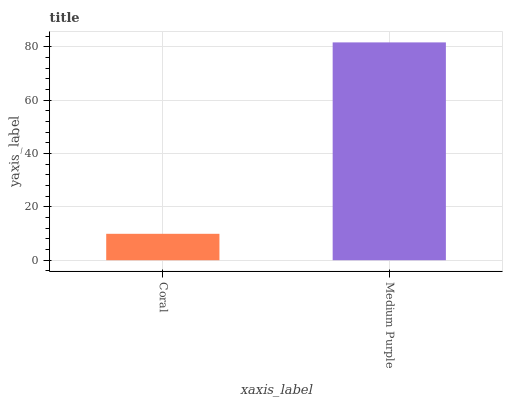Is Coral the minimum?
Answer yes or no. Yes. Is Medium Purple the maximum?
Answer yes or no. Yes. Is Medium Purple the minimum?
Answer yes or no. No. Is Medium Purple greater than Coral?
Answer yes or no. Yes. Is Coral less than Medium Purple?
Answer yes or no. Yes. Is Coral greater than Medium Purple?
Answer yes or no. No. Is Medium Purple less than Coral?
Answer yes or no. No. Is Medium Purple the high median?
Answer yes or no. Yes. Is Coral the low median?
Answer yes or no. Yes. Is Coral the high median?
Answer yes or no. No. Is Medium Purple the low median?
Answer yes or no. No. 